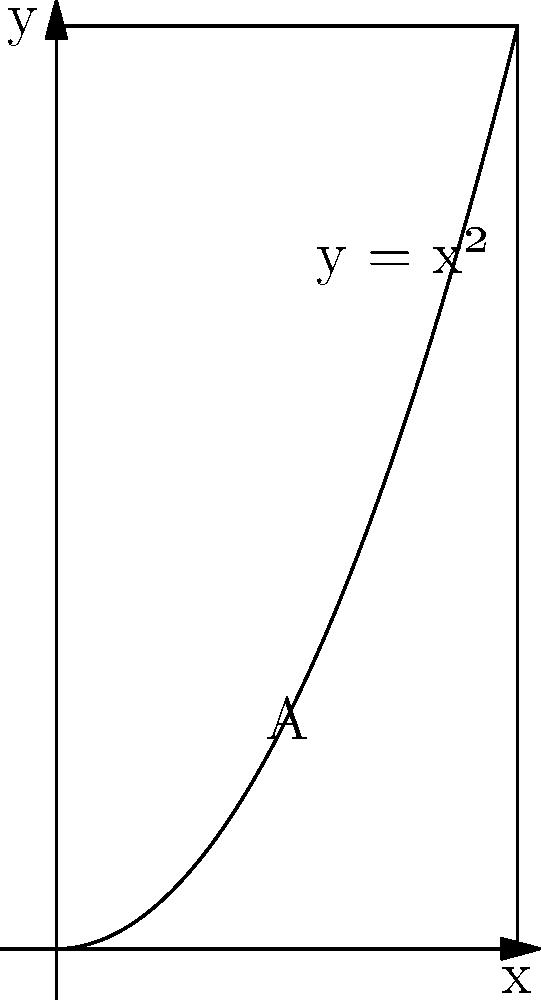Calculate the area $A$ bounded by the curve $y = x^2$, the x-axis, and the line $x = 2$ using integration. To find the area under the curve, we need to integrate the function $y = x^2$ from $x = 0$ to $x = 2$. Here's the step-by-step solution:

1) The area is given by the definite integral:
   $$A = \int_0^2 x^2 \, dx$$

2) To integrate $x^2$, we use the power rule: $\int x^n \, dx = \frac{x^{n+1}}{n+1} + C$
   In this case, $n = 2$, so:
   $$\int x^2 \, dx = \frac{x^3}{3} + C$$

3) Now we can evaluate the definite integral:
   $$A = \left[\frac{x^3}{3}\right]_0^2$$

4) Substitute the upper and lower limits:
   $$A = \frac{2^3}{3} - \frac{0^3}{3} = \frac{8}{3} - 0 = \frac{8}{3}$$

Therefore, the area under the curve is $\frac{8}{3}$ square units.
Answer: $\frac{8}{3}$ square units 